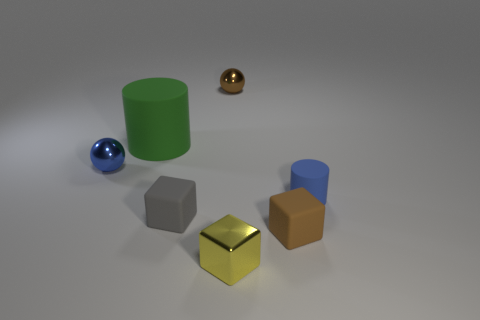Does the brown rubber cube have the same size as the cylinder that is behind the small blue sphere?
Your answer should be very brief. No. What number of rubber objects are either blue cylinders or tiny spheres?
Your answer should be very brief. 1. How many tiny blue metal objects are the same shape as the tiny brown metallic object?
Provide a short and direct response. 1. There is a small sphere that is the same color as the small cylinder; what is its material?
Give a very brief answer. Metal. There is a blue thing that is on the right side of the big green matte cylinder; does it have the same size as the brown object in front of the big rubber cylinder?
Your answer should be compact. Yes. There is a brown thing behind the tiny brown matte block; what shape is it?
Provide a short and direct response. Sphere. There is another object that is the same shape as the green object; what is its material?
Provide a short and direct response. Rubber. There is a green thing that is to the left of the gray rubber object; is it the same size as the blue rubber object?
Ensure brevity in your answer.  No. There is a tiny brown matte cube; how many big rubber cylinders are in front of it?
Give a very brief answer. 0. Is the number of brown objects to the right of the big green matte cylinder less than the number of tiny brown rubber things in front of the yellow shiny cube?
Make the answer very short. No. 